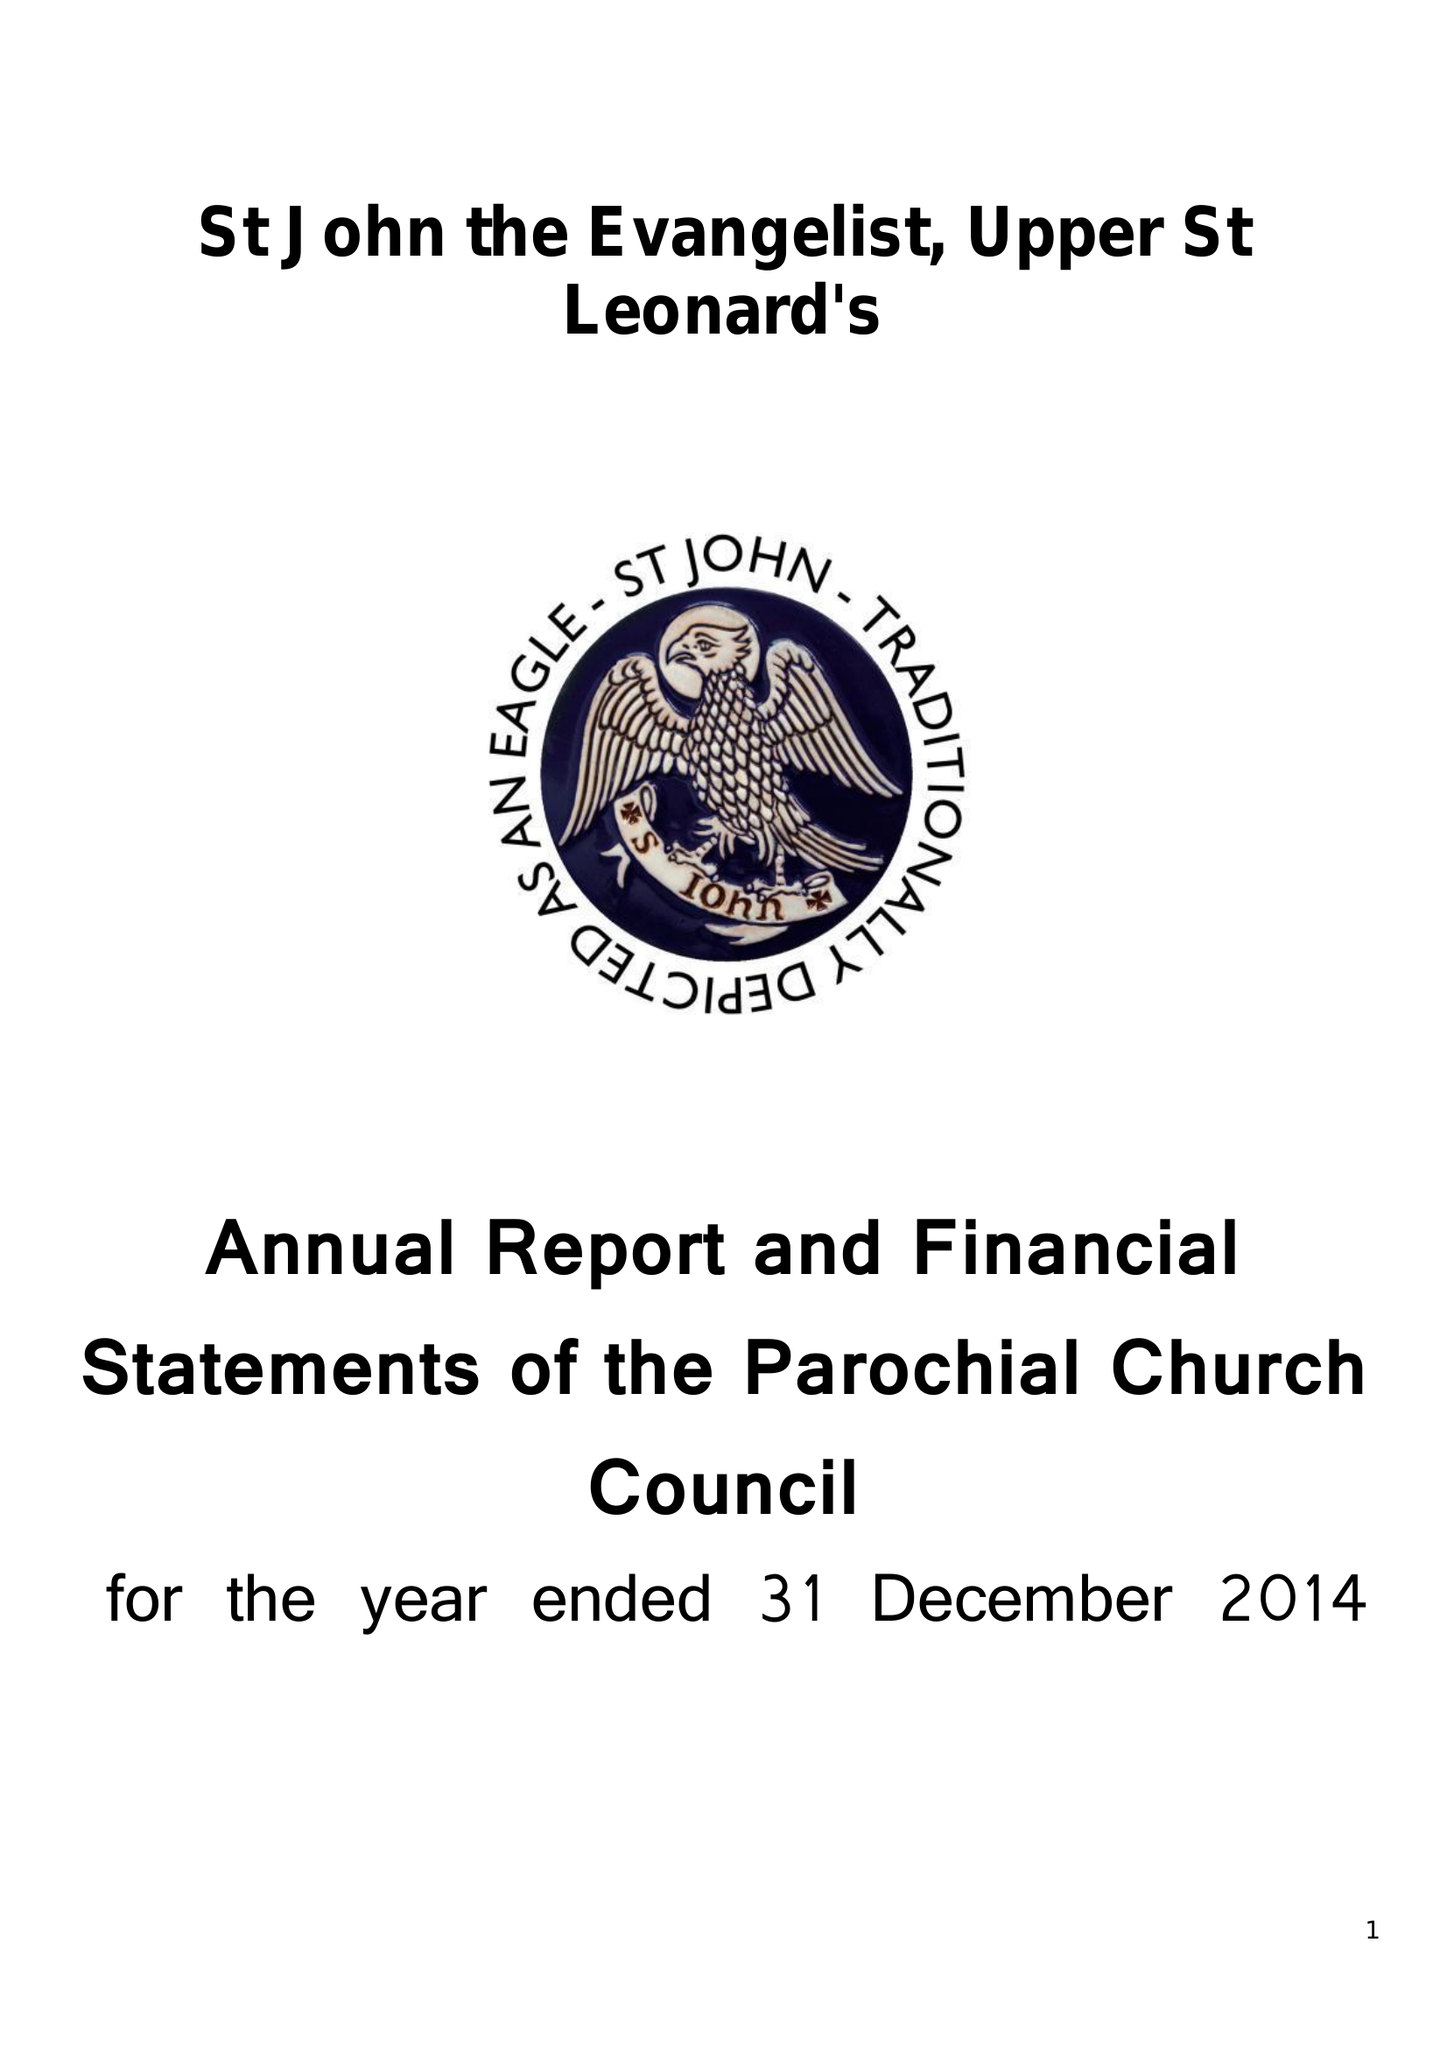What is the value for the charity_name?
Answer the question using a single word or phrase. The Parochial Church Council Of The Ecclesiastical Parish Of St John The Evangelist Upper St Leonards On Sea 